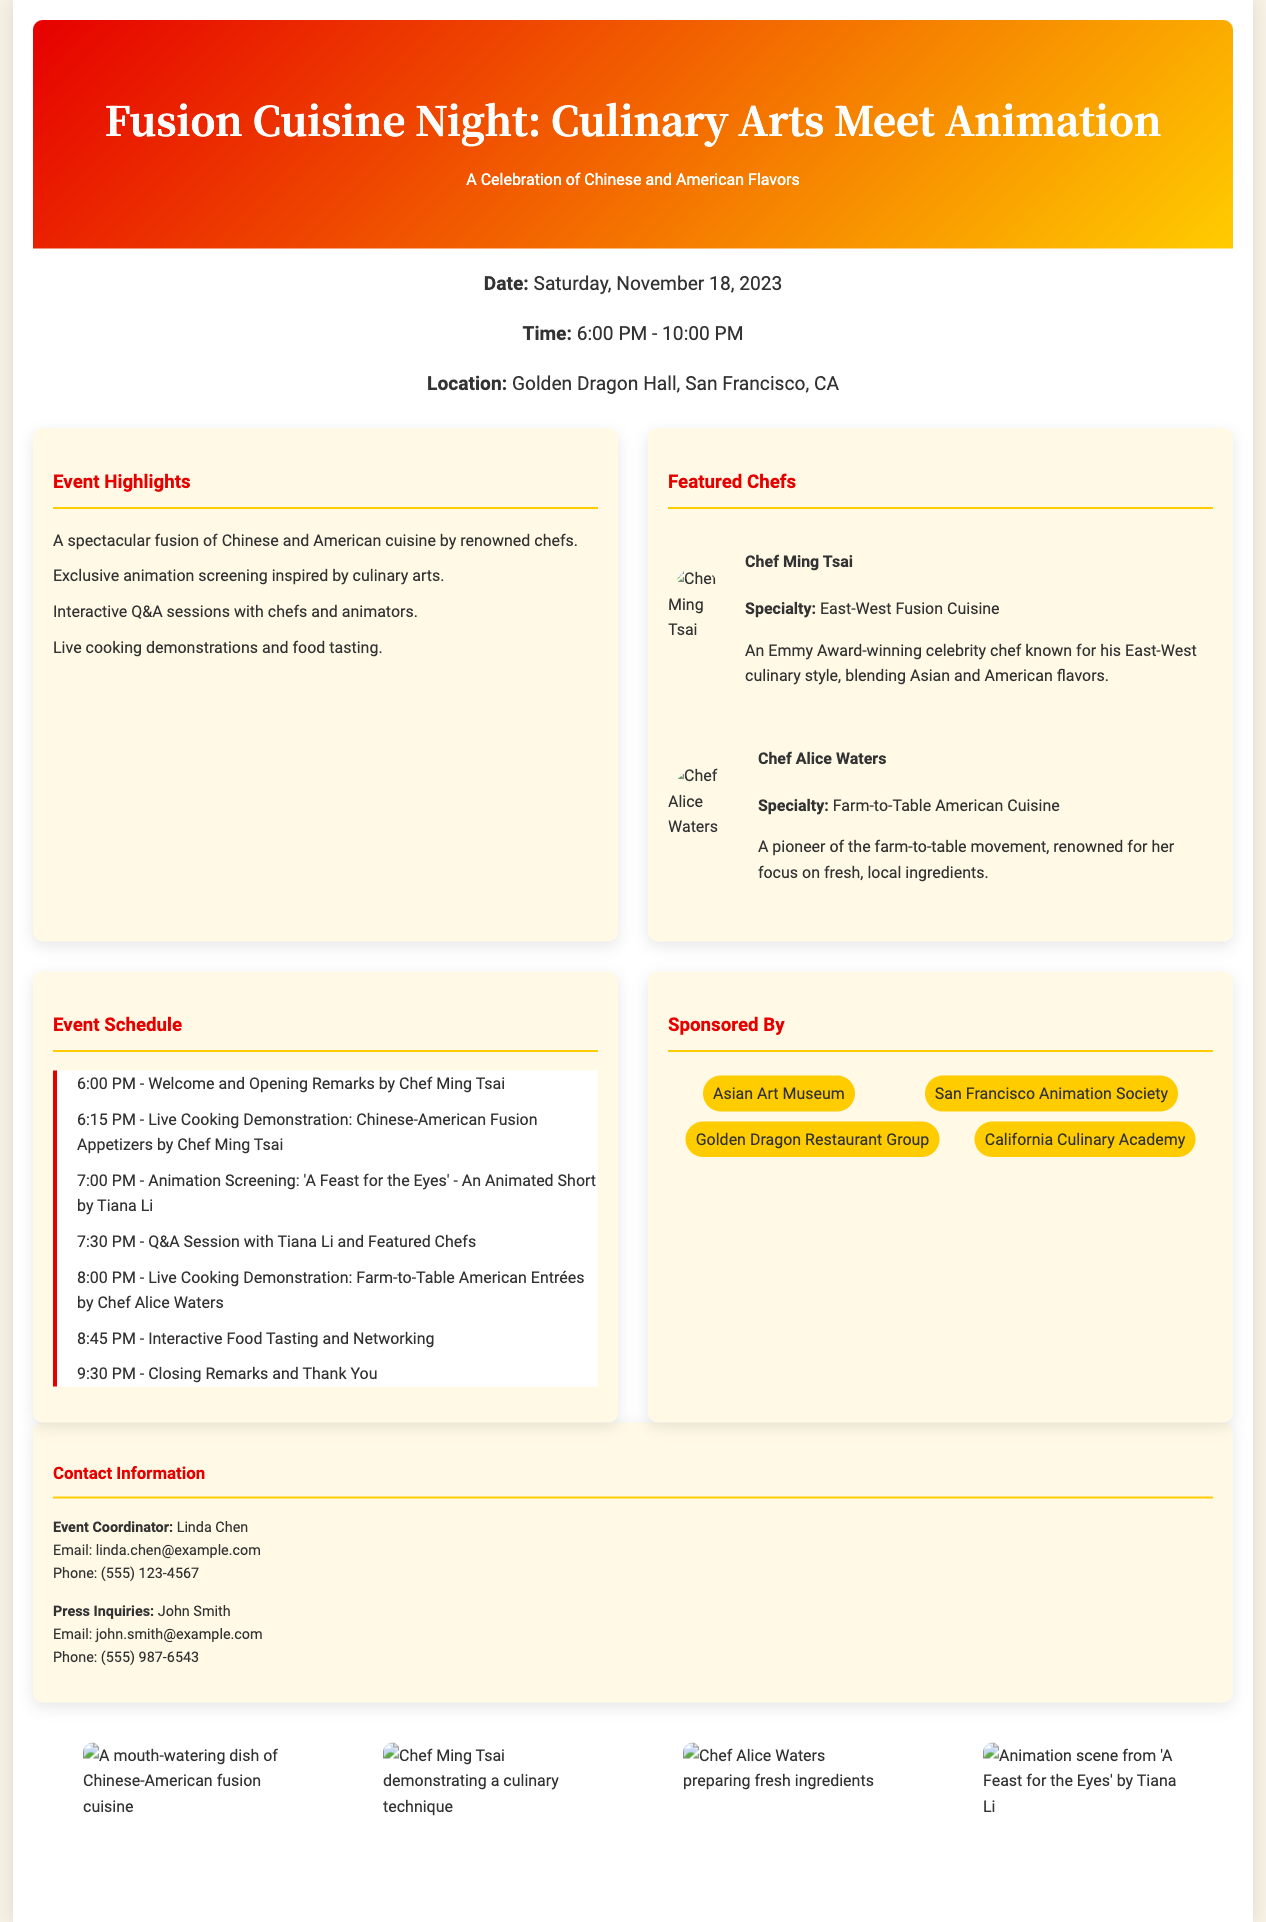What is the date of the event? The date of the event is specified in the document as Saturday, November 18, 2023.
Answer: Saturday, November 18, 2023 What is the location of the Fusion Cuisine Night? The location is mentioned in the document to be Golden Dragon Hall, San Francisco, CA.
Answer: Golden Dragon Hall, San Francisco, CA Who are the featured chefs? The document lists Chef Ming Tsai and Chef Alice Waters as featured chefs.
Answer: Chef Ming Tsai and Chef Alice Waters What time does the live cooking demonstration by Chef Alice Waters start? The schedule indicates that her demonstration starts at 8:00 PM.
Answer: 8:00 PM What is the title of the animated short being screened? The title of the animation screening is 'A Feast for the Eyes'.
Answer: 'A Feast for the Eyes' How many hours does the event last? The event is scheduled from 6:00 PM to 10:00 PM, lasting 4 hours in total.
Answer: 4 hours What type of cuisine will be demonstrated by Chef Ming Tsai? The document specifies that Chef Ming Tsai will demonstrate Chinese-American Fusion Appetizers.
Answer: Chinese-American Fusion Appetizers What is the name of the event coordinator? The event coordinator is named Linda Chen as mentioned in the contact section.
Answer: Linda Chen Which organization sponsors the event? The document lists several sponsors, including Asian Art Museum, San Francisco Animation Society, Golden Dragon Restaurant Group, and California Culinary Academy.
Answer: Asian Art Museum, San Francisco Animation Society, Golden Dragon Restaurant Group, California Culinary Academy 